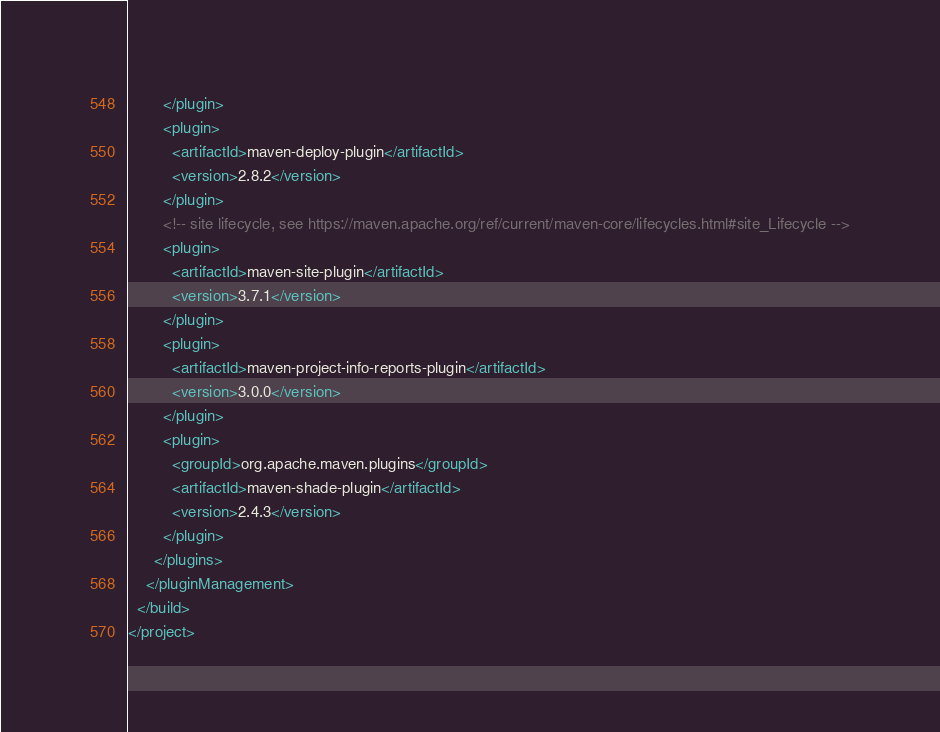Convert code to text. <code><loc_0><loc_0><loc_500><loc_500><_XML_>        </plugin>
        <plugin>
          <artifactId>maven-deploy-plugin</artifactId>
          <version>2.8.2</version>
        </plugin>
        <!-- site lifecycle, see https://maven.apache.org/ref/current/maven-core/lifecycles.html#site_Lifecycle -->
        <plugin>
          <artifactId>maven-site-plugin</artifactId>
          <version>3.7.1</version>
        </plugin>
        <plugin>
          <artifactId>maven-project-info-reports-plugin</artifactId>
          <version>3.0.0</version>
        </plugin>
        <plugin>
          <groupId>org.apache.maven.plugins</groupId>
          <artifactId>maven-shade-plugin</artifactId>
          <version>2.4.3</version>
        </plugin>
      </plugins>
    </pluginManagement>
  </build>
</project>
</code> 